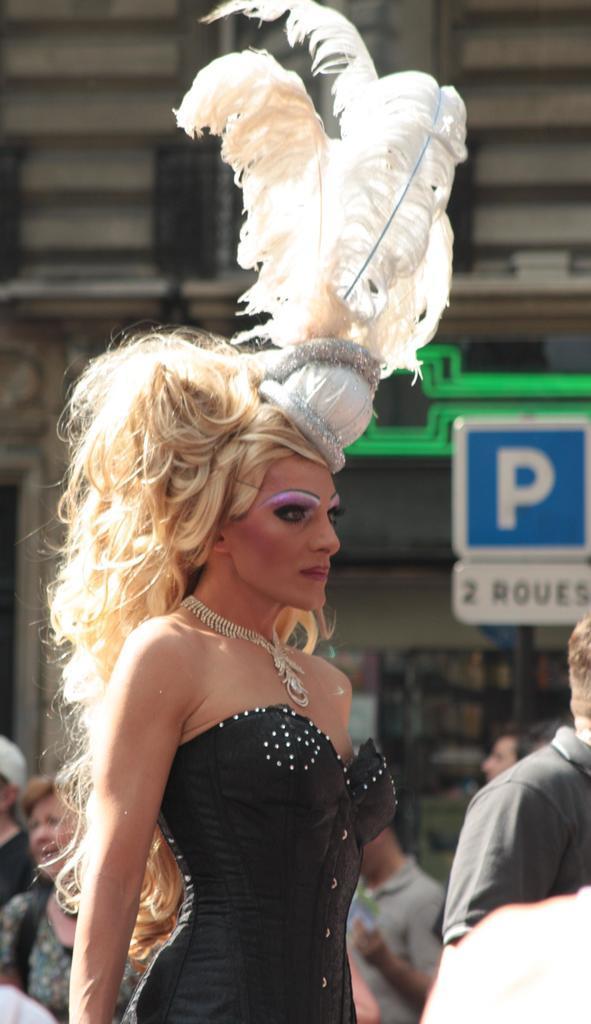Please provide a concise description of this image. Here I can see a woman wearing a costume and standing facing towards the right side. At the back of her there are many people standing. In the background I can see a part of a building. On the right side there is a board on which I can see some text. 